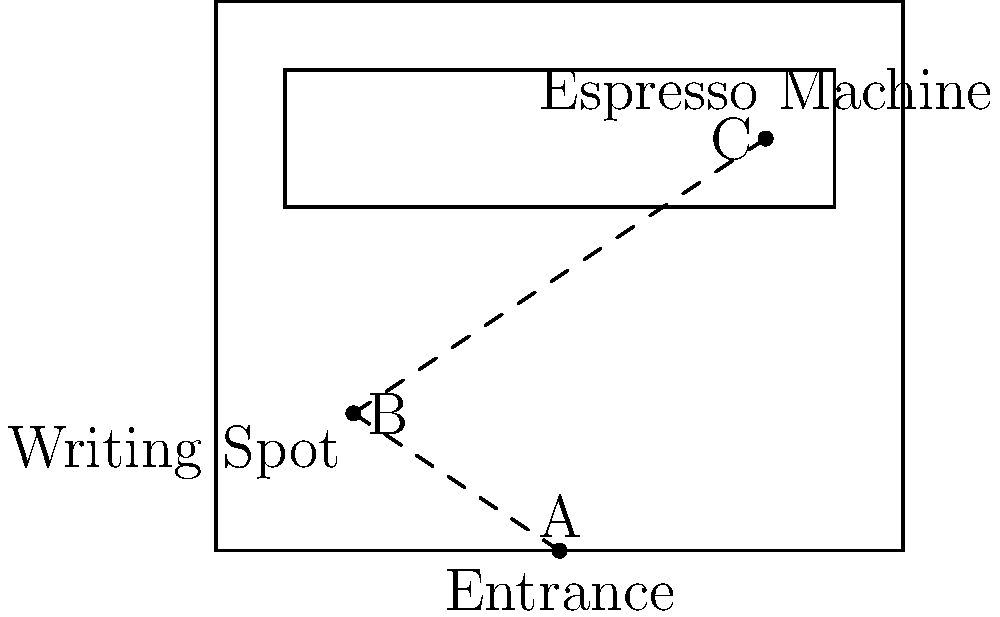In the coffee shop floor plan shown, a freelance writer enters at point A (the entrance) and walks to their favorite writing spot at point B. Later, they decide to get an espresso from the machine located at point C. If the distance from A to B is 5 meters and the distance from B to C is 7 meters, what is the shortest possible distance, in meters, from A to C (directly from the entrance to the espresso machine)? To solve this problem, we can use the Triangle Inequality Theorem, which states that the sum of the lengths of any two sides of a triangle must be greater than the length of the remaining side. In this case, we're looking for the shortest possible distance from A to C, which would be a straight line.

Let's approach this step-by-step:

1) We know:
   AB = 5 meters
   BC = 7 meters

2) Let's denote AC (the unknown distance) as x meters.

3) According to the Triangle Inequality Theorem:
   AB + BC > AC
   AC + AB > BC
   AC + BC > AB

4) From the third inequality:
   x + 7 > 5
   x > -2  (This is always true for positive distances)

5) From the second inequality:
   x + 5 > 7
   x > 2

6) From the first inequality:
   5 + 7 > x
   12 > x

7) Combining the results from steps 5 and 6:
   2 < x < 12

Therefore, the shortest possible distance from A to C must be just slightly more than 2 meters. The exact distance would depend on the precise layout of the coffee shop, but based on the given information, we can conclude that the minimum possible distance is slightly more than 2 meters.
Answer: Slightly more than 2 meters 